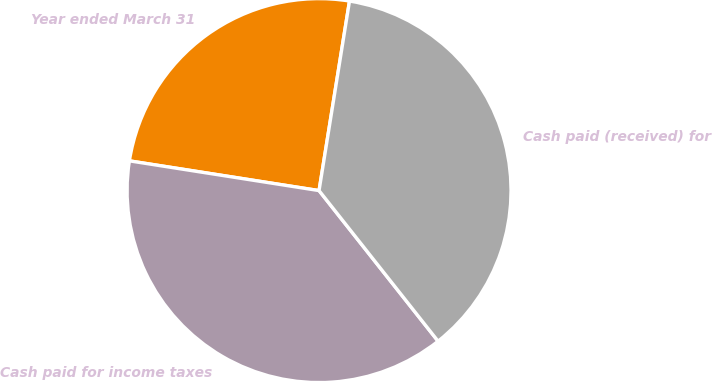Convert chart. <chart><loc_0><loc_0><loc_500><loc_500><pie_chart><fcel>Year ended March 31<fcel>Cash paid for income taxes<fcel>Cash paid (received) for<nl><fcel>25.06%<fcel>38.12%<fcel>36.82%<nl></chart> 